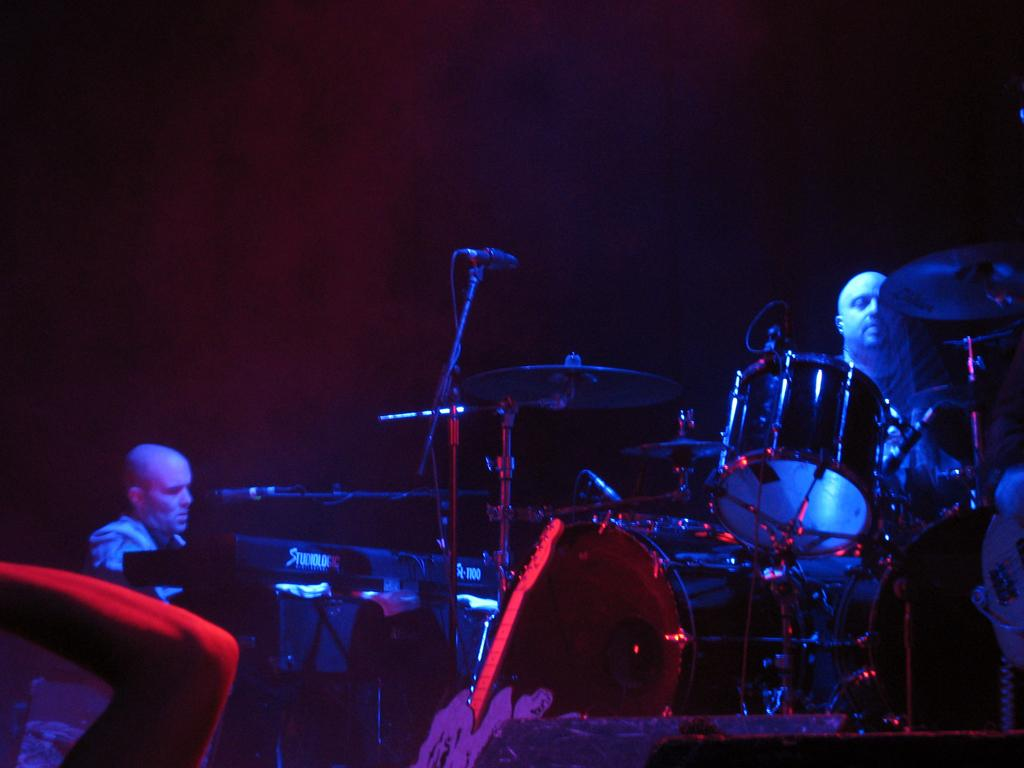Who or what can be seen in the image? There are people in the image. What are the people doing in the image? The people are playing musical instruments in the image. What object is present that is commonly used for amplifying sound? There is a microphone in the image. Can you see a snail crawling on the microphone in the image? No, there is no snail present in the image. 